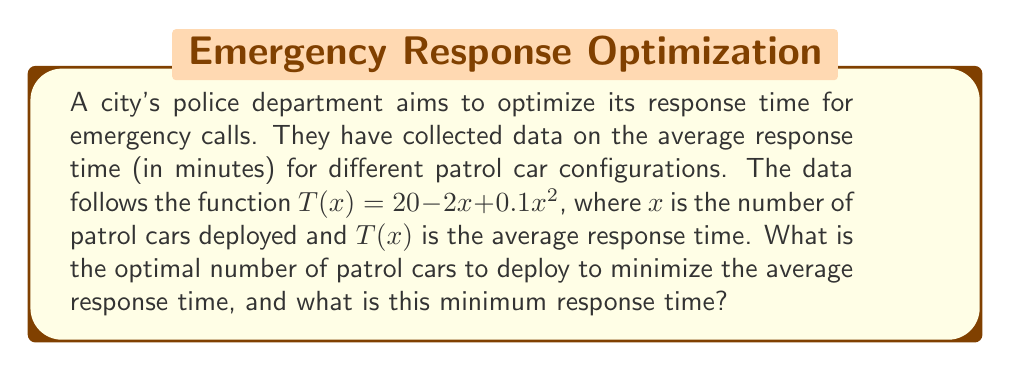Teach me how to tackle this problem. To find the optimal number of patrol cars and the minimum response time, we need to follow these steps:

1) The function $T(x) = 20 - 2x + 0.1x^2$ represents a quadratic equation. To find the minimum point, we need to find where the derivative equals zero.

2) Let's find the derivative of $T(x)$:
   $$T'(x) = -2 + 0.2x$$

3) Set the derivative equal to zero and solve for $x$:
   $$-2 + 0.2x = 0$$
   $$0.2x = 2$$
   $$x = 10$$

4) To confirm this is a minimum (not a maximum), we can check the second derivative:
   $$T''(x) = 0.2$$
   Since this is positive, we confirm that $x = 10$ gives a minimum.

5) Now that we know the optimal number of patrol cars is 10, let's calculate the minimum response time by plugging this value back into our original function:

   $$T(10) = 20 - 2(10) + 0.1(10)^2$$
   $$= 20 - 20 + 10$$
   $$= 10$$

Therefore, the optimal number of patrol cars to deploy is 10, and the minimum average response time is 10 minutes.
Answer: 10 patrol cars; 10 minutes 